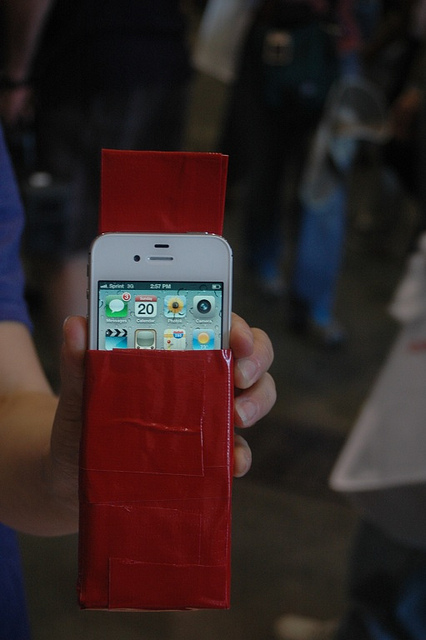Please identify all text content in this image. 20 